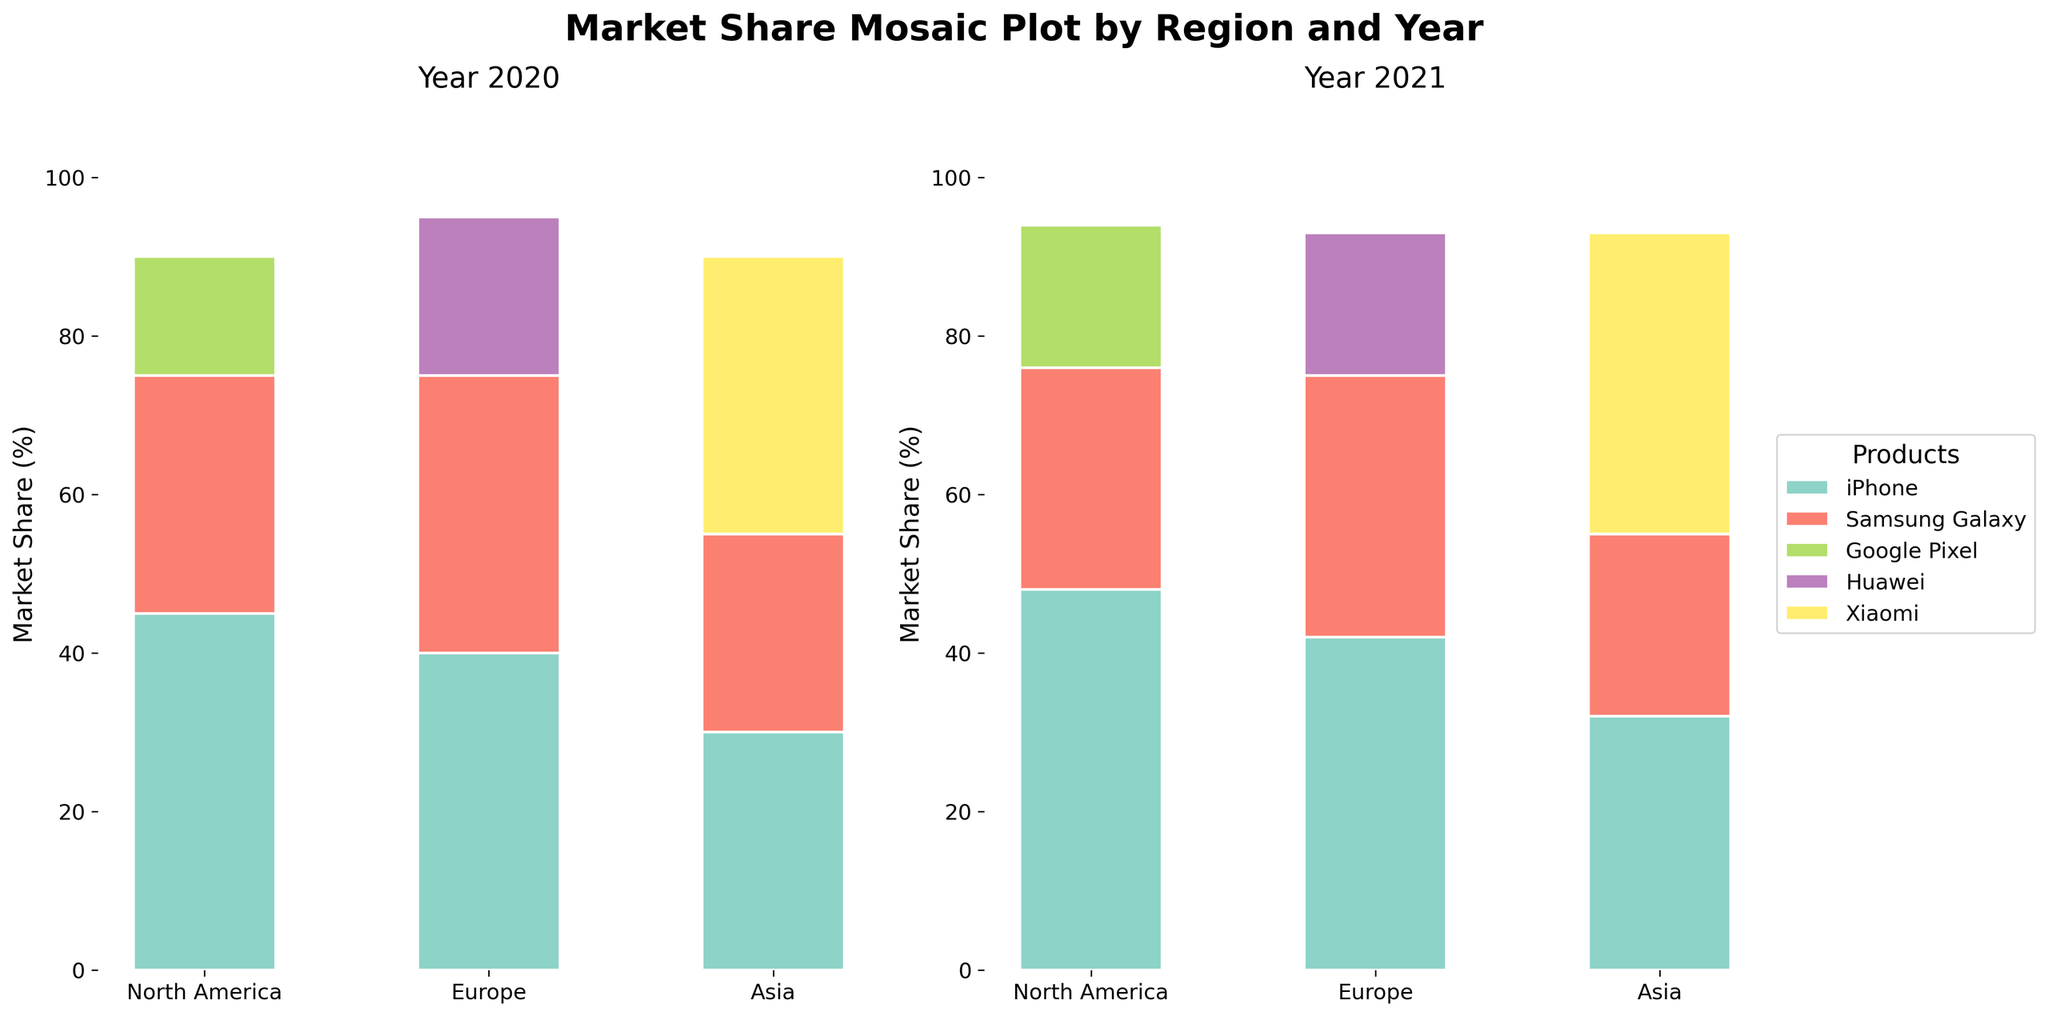What is the title of the figure? The title is usually located at the top of the figure and summarizes its content. Here, it reads 'Market Share Mosaic Plot by Region and Year.'
Answer: Market Share Mosaic Plot by Region and Year How does the market share of the iPhone in North America change from 2020 to 2021? Look at the height of the iPhone's section for North America in 2020 and compare it to 2021. The height increases from 45% to 48%.
Answer: It increases by 3% Which product has the highest market share in Asia in 2021? Find the segment for 2021 in the Asia region and compare the heights of all products. Xiaomi has the highest bar at 38%.
Answer: Xiaomi Which region saw the most significant increase in the iPhone's market share between 2020 and 2021? For each region, subtract the 2020 market share from the 2021 market share for the iPhone. North America: 48% - 45% = 3%, Europe: 42% - 40% = 2%, Asia: 32% - 30% = 2%. North America has the highest increase.
Answer: North America Compare the market share of Samsung Galaxy in Europe and Asia in 2021. Which region is higher? For 2021, find the Samsung Galaxy bar in Europe and Asia, then compare their heights. Europe has 33%, and Asia has 23%.
Answer: Europe What is the combined market share of the iPhone and Samsung Galaxy in North America in 2021? Add the market shares of the iPhone (48%) and Samsung Galaxy (28%) in North America for 2021: 48% + 28% = 76%.
Answer: 76% Did Huawei's market share in Europe increase or decrease from 2020 to 2021, and by how much? Compare the heights of Huawei's segment for Europe between 2020 and 2021. It decreased from 20% to 18%. The decrease is 20% - 18% = 2%.
Answer: Decrease by 2% Which year shows a greater total market share for the Google Pixel in North America? Compare the market share of Google Pixel between 2020 and 2021 in North America. 2020 has 15%, and 2021 has 18%.
Answer: 2021 What two products have the closest market share in Europe in 2021? For 2021 in Europe, compare the heights of segments to find the closest values. Samsung Galaxy (33%) and Huawei (18%) are closest, but iPhone (42%) and Samsung Galaxy (33%) are closer, with a difference of 9%.
Answer: iPhone and Samsung Galaxy In which region does the market share of Xiaomi decrease from 2020 to 2021? Compare the heights of the Xiaomi segments between 2020 and 2021 for each region. Xiaomi is only presented in Asia, where it increases from 35% to 38%. Therefore, Xiaomi does not decrease in any region.
Answer: None 